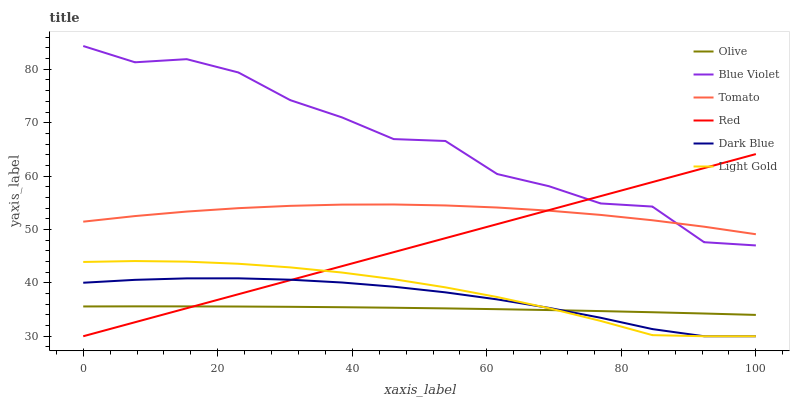Does Olive have the minimum area under the curve?
Answer yes or no. Yes. Does Blue Violet have the maximum area under the curve?
Answer yes or no. Yes. Does Dark Blue have the minimum area under the curve?
Answer yes or no. No. Does Dark Blue have the maximum area under the curve?
Answer yes or no. No. Is Red the smoothest?
Answer yes or no. Yes. Is Blue Violet the roughest?
Answer yes or no. Yes. Is Dark Blue the smoothest?
Answer yes or no. No. Is Dark Blue the roughest?
Answer yes or no. No. Does Dark Blue have the lowest value?
Answer yes or no. Yes. Does Blue Violet have the lowest value?
Answer yes or no. No. Does Blue Violet have the highest value?
Answer yes or no. Yes. Does Dark Blue have the highest value?
Answer yes or no. No. Is Olive less than Tomato?
Answer yes or no. Yes. Is Tomato greater than Olive?
Answer yes or no. Yes. Does Red intersect Dark Blue?
Answer yes or no. Yes. Is Red less than Dark Blue?
Answer yes or no. No. Is Red greater than Dark Blue?
Answer yes or no. No. Does Olive intersect Tomato?
Answer yes or no. No. 